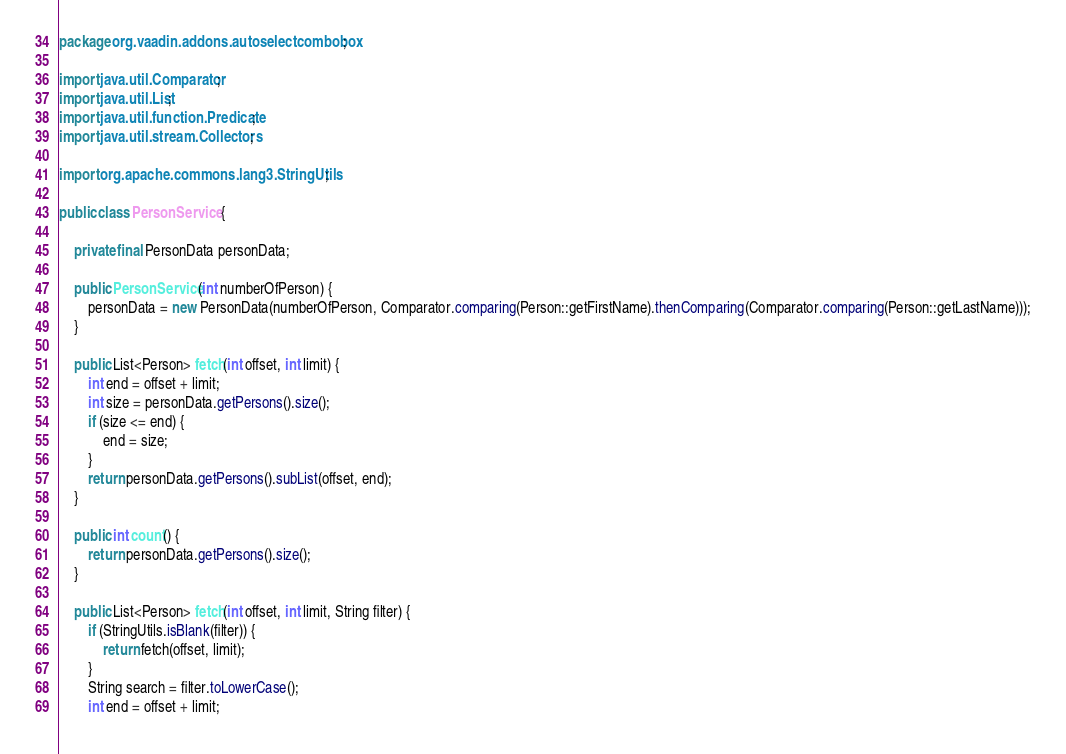<code> <loc_0><loc_0><loc_500><loc_500><_Java_>package org.vaadin.addons.autoselectcombobox;

import java.util.Comparator;
import java.util.List;
import java.util.function.Predicate;
import java.util.stream.Collectors;

import org.apache.commons.lang3.StringUtils;

public class PersonService {

    private final PersonData personData;

    public PersonService(int numberOfPerson) {
        personData = new PersonData(numberOfPerson, Comparator.comparing(Person::getFirstName).thenComparing(Comparator.comparing(Person::getLastName)));
    }

    public List<Person> fetch(int offset, int limit) {
        int end = offset + limit;
        int size = personData.getPersons().size();
        if (size <= end) {
            end = size;
        }
        return personData.getPersons().subList(offset, end);
    }

    public int count() {
        return personData.getPersons().size();
    }

    public List<Person> fetch(int offset, int limit, String filter) {
        if (StringUtils.isBlank(filter)) {
            return fetch(offset, limit);
        }
        String search = filter.toLowerCase();
        int end = offset + limit;</code> 